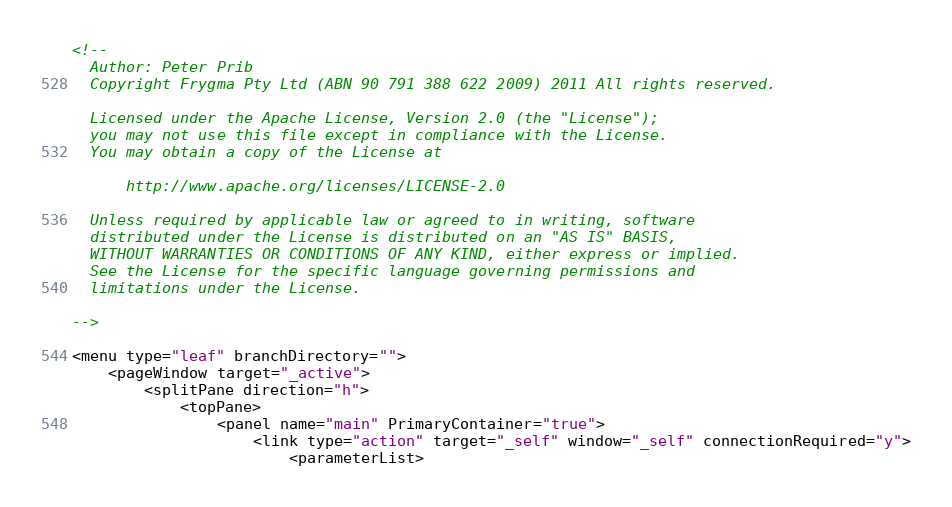<code> <loc_0><loc_0><loc_500><loc_500><_XML_><!--
  Author: Peter Prib
  Copyright Frygma Pty Ltd (ABN 90 791 388 622 2009) 2011 All rights reserved.

  Licensed under the Apache License, Version 2.0 (the "License");
  you may not use this file except in compliance with the License.
  You may obtain a copy of the License at

      http://www.apache.org/licenses/LICENSE-2.0

  Unless required by applicable law or agreed to in writing, software
  distributed under the License is distributed on an "AS IS" BASIS,
  WITHOUT WARRANTIES OR CONDITIONS OF ANY KIND, either express or implied.
  See the License for the specific language governing permissions and
  limitations under the License.
  
-->

<menu type="leaf" branchDirectory="">
	<pageWindow target="_active">
		<splitPane direction="h">
			<topPane>
				<panel name="main" PrimaryContainer="true">
					<link type="action" target="_self" window="_self" connectionRequired="y">
						<parameterList></code> 